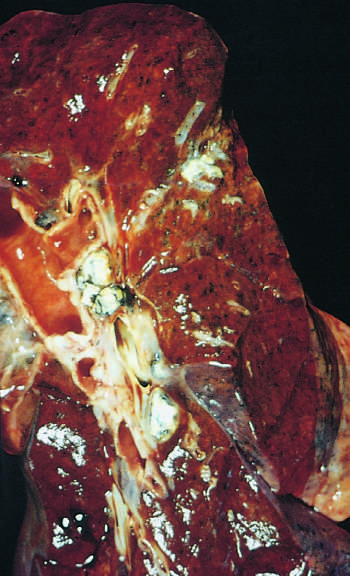what is under the pleura in the lower part of the upper lobe?
Answer the question using a single word or phrase. The gray-white parenchymal focus 